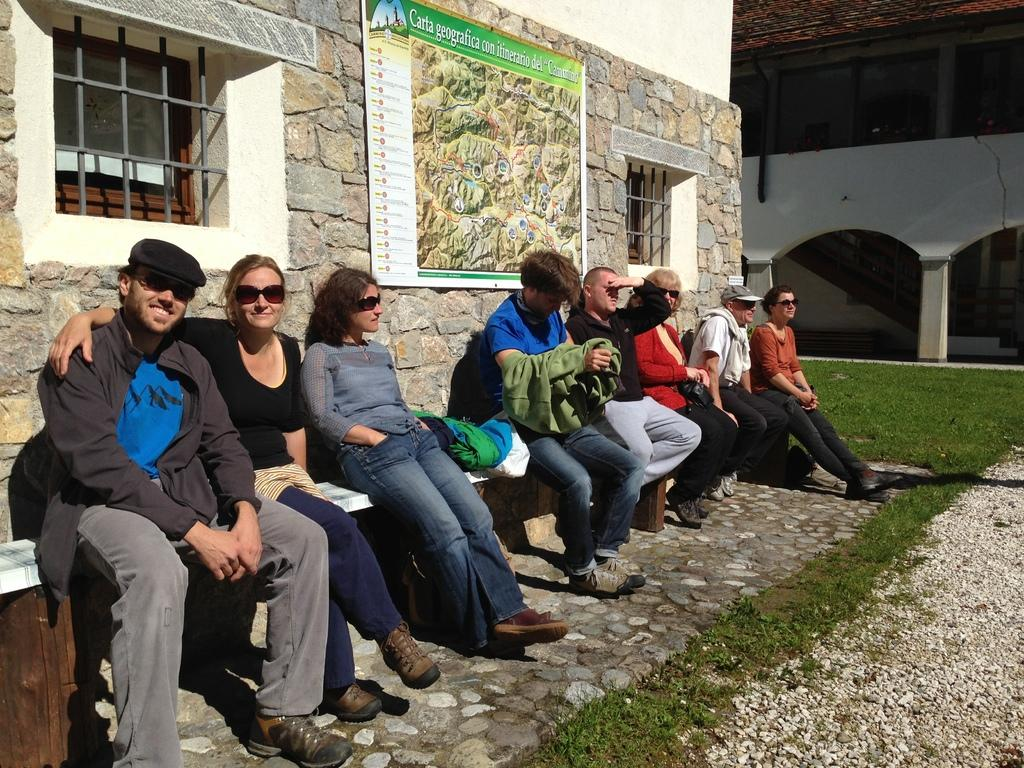What are the people in the image doing? The people in the image are sitting on a bench. How is the bench positioned in the image? The bench is laid against a wall. What can be seen in the background of the image? There is a house in the background of the image. What type of weather can be seen in the image? The provided facts do not mention any weather conditions, so it cannot be determined from the image. 